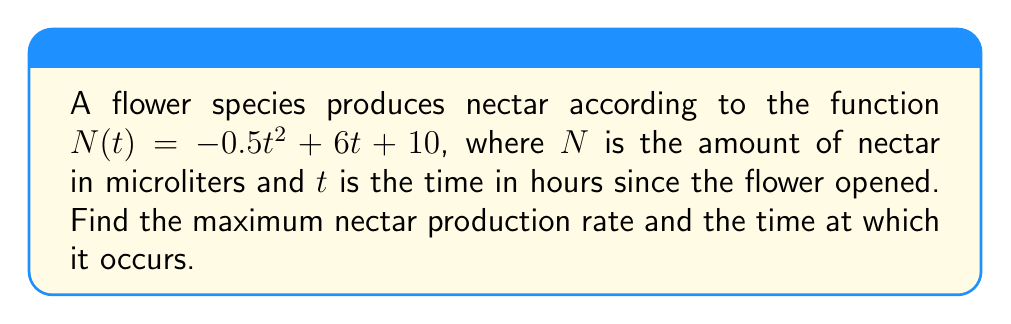Show me your answer to this math problem. 1) To find the maximum nectar production rate, we need to find the derivative of $N(t)$ with respect to $t$:

   $N'(t) = \frac{d}{dt}(-0.5t^2 + 6t + 10) = -t + 6$

2) The nectar production rate is given by $N'(t)$, which is the rate of change of nectar amount with respect to time.

3) To find the maximum rate, we need to find where $N'(t)$ reaches its highest point. Since $N'(t)$ is a linear function, its maximum will occur at one of the endpoints of the domain or where its derivative equals zero.

4) Let's find where $N'(t) = 0$:

   $-t + 6 = 0$
   $-t = -6$
   $t = 6$

5) At $t = 6$ hours, the nectar production rate is:

   $N'(6) = -(6) + 6 = 0$ microliters/hour

6) To confirm this is a maximum (not a minimum), we can check the second derivative:

   $N''(t) = \frac{d}{dt}(-t + 6) = -1$

   Since $N''(t)$ is negative, $t = 6$ indeed gives a maximum.

7) Therefore, the maximum nectar production rate occurs when $t = 6$ hours, and the rate at this time is:

   $N'(6) = 0$ microliters/hour
Answer: Maximum rate: 0 μL/hr at t = 6 hours 